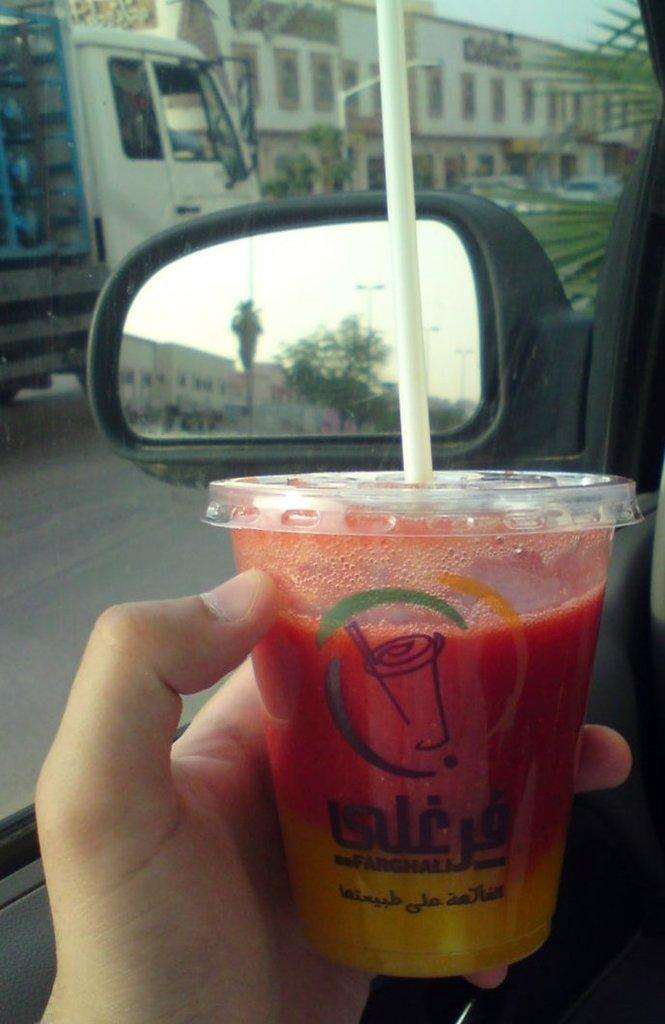Who is present in the image? There is a person in the image. What is the person holding in their hand? The person is holding a glass in their hand. What type of natural environment can be seen in the image? There are trees visible in the image. What type of man-made structures can be seen in the image? There are vehicles on the road in the image. What type of fiction is the person reading in the image? There is no book or any indication of reading in the image, so it cannot be determined if the person is reading fiction or any other type of material. 